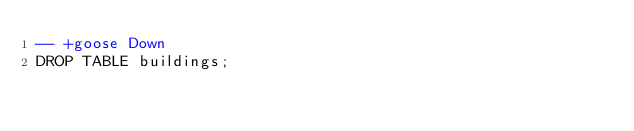<code> <loc_0><loc_0><loc_500><loc_500><_SQL_>-- +goose Down
DROP TABLE buildings;

</code> 